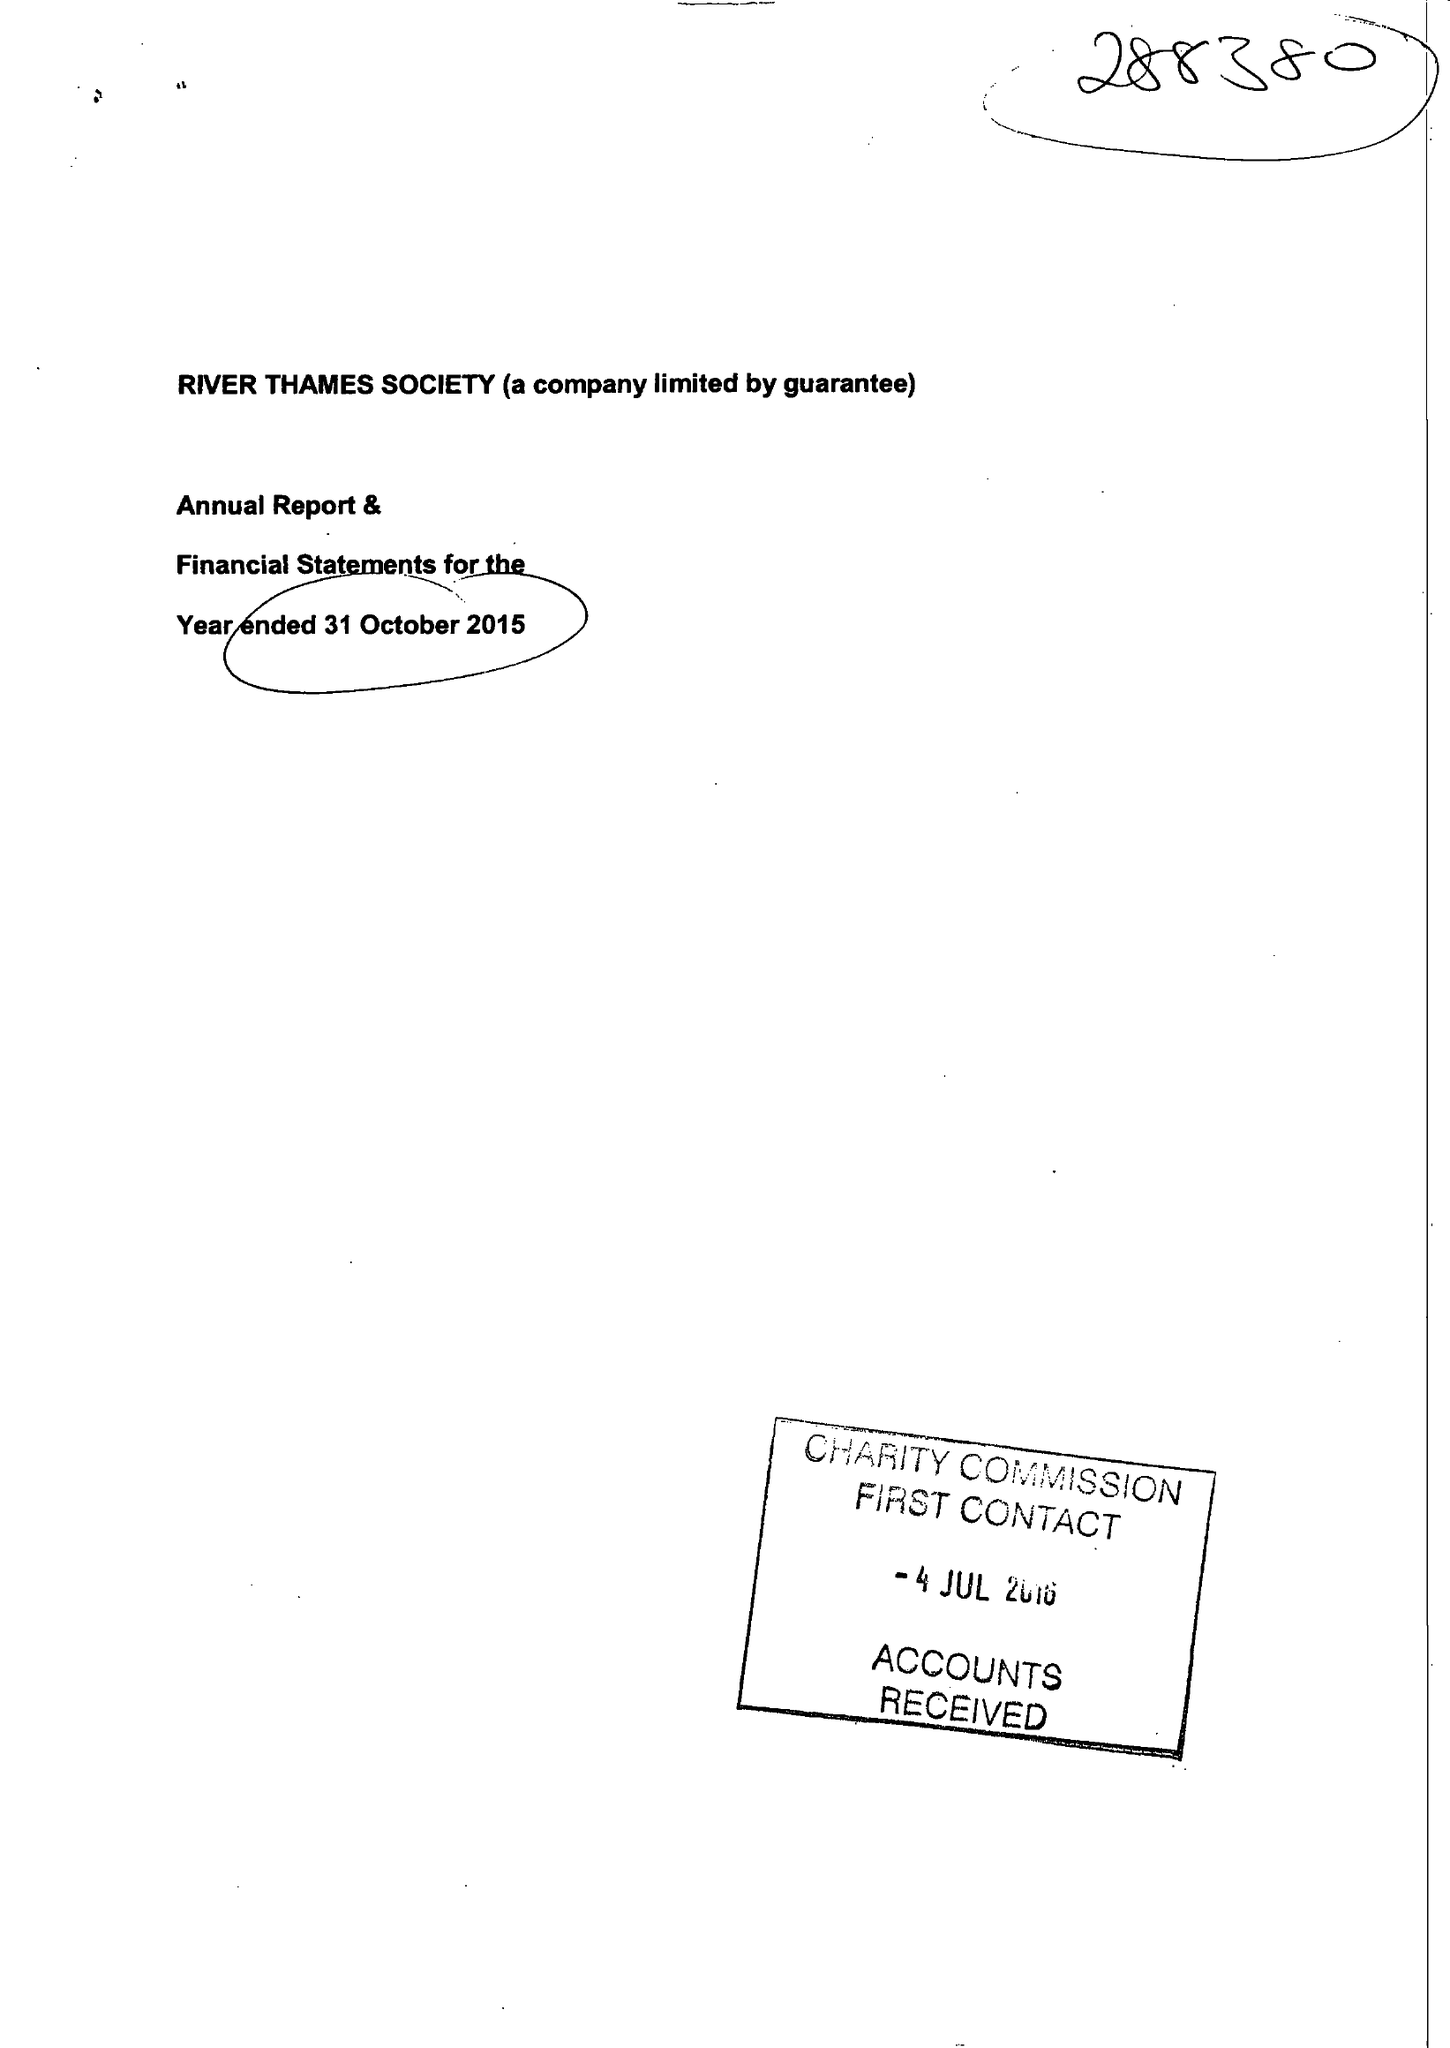What is the value for the address__post_town?
Answer the question using a single word or phrase. WINDSOR 